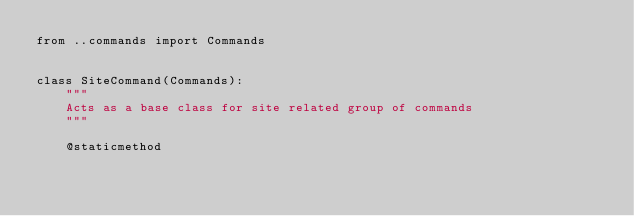<code> <loc_0><loc_0><loc_500><loc_500><_Python_>from ..commands import Commands


class SiteCommand(Commands):
    """
    Acts as a base class for site related group of commands
    """

    @staticmethod</code> 